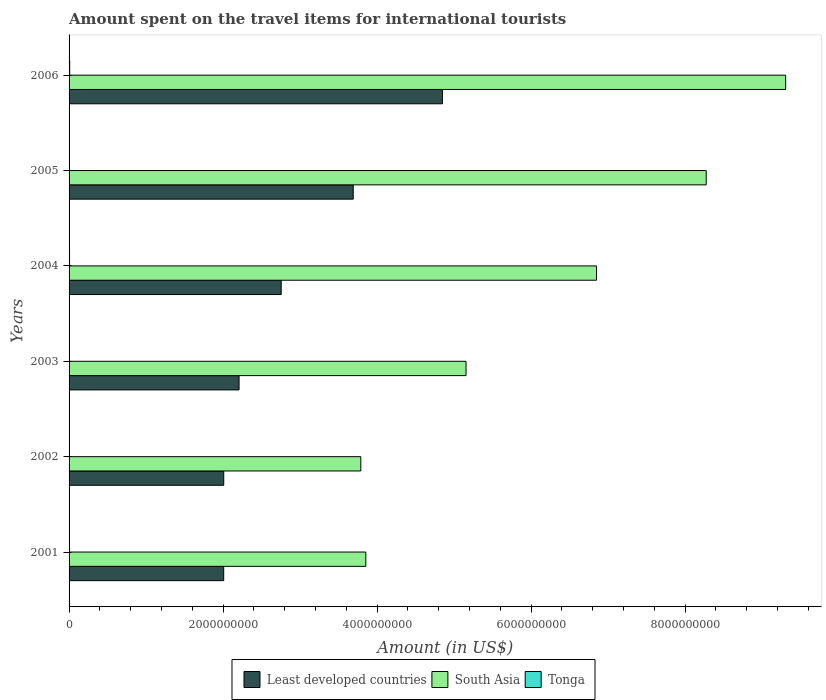Are the number of bars per tick equal to the number of legend labels?
Offer a very short reply. Yes. How many bars are there on the 2nd tick from the bottom?
Your answer should be very brief. 3. In how many cases, is the number of bars for a given year not equal to the number of legend labels?
Provide a succinct answer. 0. What is the amount spent on the travel items for international tourists in South Asia in 2006?
Keep it short and to the point. 9.31e+09. Across all years, what is the maximum amount spent on the travel items for international tourists in South Asia?
Provide a short and direct response. 9.31e+09. Across all years, what is the minimum amount spent on the travel items for international tourists in South Asia?
Offer a terse response. 3.79e+09. In which year was the amount spent on the travel items for international tourists in Tonga maximum?
Make the answer very short. 2006. What is the total amount spent on the travel items for international tourists in Tonga in the graph?
Your answer should be very brief. 2.77e+07. What is the difference between the amount spent on the travel items for international tourists in South Asia in 2005 and that in 2006?
Provide a succinct answer. -1.03e+09. What is the difference between the amount spent on the travel items for international tourists in Least developed countries in 2005 and the amount spent on the travel items for international tourists in South Asia in 2003?
Provide a succinct answer. -1.47e+09. What is the average amount spent on the travel items for international tourists in Tonga per year?
Keep it short and to the point. 4.62e+06. In the year 2002, what is the difference between the amount spent on the travel items for international tourists in Least developed countries and amount spent on the travel items for international tourists in South Asia?
Give a very brief answer. -1.78e+09. What is the ratio of the amount spent on the travel items for international tourists in South Asia in 2001 to that in 2005?
Offer a very short reply. 0.47. Is the amount spent on the travel items for international tourists in Tonga in 2003 less than that in 2004?
Your answer should be very brief. Yes. Is the difference between the amount spent on the travel items for international tourists in Least developed countries in 2003 and 2006 greater than the difference between the amount spent on the travel items for international tourists in South Asia in 2003 and 2006?
Provide a short and direct response. Yes. What is the difference between the highest and the second highest amount spent on the travel items for international tourists in Least developed countries?
Your answer should be compact. 1.16e+09. What is the difference between the highest and the lowest amount spent on the travel items for international tourists in South Asia?
Offer a terse response. 5.52e+09. What does the 3rd bar from the top in 2004 represents?
Offer a terse response. Least developed countries. What does the 1st bar from the bottom in 2004 represents?
Your answer should be very brief. Least developed countries. Is it the case that in every year, the sum of the amount spent on the travel items for international tourists in South Asia and amount spent on the travel items for international tourists in Tonga is greater than the amount spent on the travel items for international tourists in Least developed countries?
Your answer should be compact. Yes. Are all the bars in the graph horizontal?
Your response must be concise. Yes. Are the values on the major ticks of X-axis written in scientific E-notation?
Give a very brief answer. No. How are the legend labels stacked?
Offer a very short reply. Horizontal. What is the title of the graph?
Your answer should be compact. Amount spent on the travel items for international tourists. What is the Amount (in US$) of Least developed countries in 2001?
Make the answer very short. 2.01e+09. What is the Amount (in US$) of South Asia in 2001?
Give a very brief answer. 3.85e+09. What is the Amount (in US$) in Tonga in 2001?
Make the answer very short. 3.20e+06. What is the Amount (in US$) of Least developed countries in 2002?
Keep it short and to the point. 2.01e+09. What is the Amount (in US$) of South Asia in 2002?
Provide a short and direct response. 3.79e+09. What is the Amount (in US$) of Tonga in 2002?
Make the answer very short. 3.20e+06. What is the Amount (in US$) of Least developed countries in 2003?
Offer a terse response. 2.21e+09. What is the Amount (in US$) in South Asia in 2003?
Make the answer very short. 5.16e+09. What is the Amount (in US$) in Tonga in 2003?
Your answer should be very brief. 3.30e+06. What is the Amount (in US$) of Least developed countries in 2004?
Your answer should be compact. 2.75e+09. What is the Amount (in US$) in South Asia in 2004?
Your answer should be very brief. 6.85e+09. What is the Amount (in US$) of Tonga in 2004?
Keep it short and to the point. 6.10e+06. What is the Amount (in US$) of Least developed countries in 2005?
Your answer should be very brief. 3.69e+09. What is the Amount (in US$) in South Asia in 2005?
Make the answer very short. 8.28e+09. What is the Amount (in US$) of Tonga in 2005?
Give a very brief answer. 3.80e+06. What is the Amount (in US$) of Least developed countries in 2006?
Your answer should be compact. 4.85e+09. What is the Amount (in US$) in South Asia in 2006?
Offer a terse response. 9.31e+09. What is the Amount (in US$) in Tonga in 2006?
Offer a very short reply. 8.10e+06. Across all years, what is the maximum Amount (in US$) of Least developed countries?
Your response must be concise. 4.85e+09. Across all years, what is the maximum Amount (in US$) of South Asia?
Give a very brief answer. 9.31e+09. Across all years, what is the maximum Amount (in US$) in Tonga?
Your response must be concise. 8.10e+06. Across all years, what is the minimum Amount (in US$) of Least developed countries?
Keep it short and to the point. 2.01e+09. Across all years, what is the minimum Amount (in US$) of South Asia?
Provide a succinct answer. 3.79e+09. Across all years, what is the minimum Amount (in US$) in Tonga?
Your answer should be compact. 3.20e+06. What is the total Amount (in US$) in Least developed countries in the graph?
Ensure brevity in your answer.  1.75e+1. What is the total Amount (in US$) of South Asia in the graph?
Make the answer very short. 3.72e+1. What is the total Amount (in US$) of Tonga in the graph?
Give a very brief answer. 2.77e+07. What is the difference between the Amount (in US$) of Least developed countries in 2001 and that in 2002?
Offer a very short reply. -4.81e+05. What is the difference between the Amount (in US$) in South Asia in 2001 and that in 2002?
Keep it short and to the point. 6.49e+07. What is the difference between the Amount (in US$) in Tonga in 2001 and that in 2002?
Your answer should be compact. 0. What is the difference between the Amount (in US$) in Least developed countries in 2001 and that in 2003?
Your answer should be compact. -1.99e+08. What is the difference between the Amount (in US$) of South Asia in 2001 and that in 2003?
Offer a very short reply. -1.30e+09. What is the difference between the Amount (in US$) of Least developed countries in 2001 and that in 2004?
Provide a succinct answer. -7.47e+08. What is the difference between the Amount (in US$) in South Asia in 2001 and that in 2004?
Provide a succinct answer. -3.00e+09. What is the difference between the Amount (in US$) in Tonga in 2001 and that in 2004?
Offer a terse response. -2.90e+06. What is the difference between the Amount (in US$) in Least developed countries in 2001 and that in 2005?
Offer a very short reply. -1.68e+09. What is the difference between the Amount (in US$) of South Asia in 2001 and that in 2005?
Keep it short and to the point. -4.42e+09. What is the difference between the Amount (in US$) in Tonga in 2001 and that in 2005?
Provide a succinct answer. -6.00e+05. What is the difference between the Amount (in US$) in Least developed countries in 2001 and that in 2006?
Provide a short and direct response. -2.84e+09. What is the difference between the Amount (in US$) in South Asia in 2001 and that in 2006?
Offer a very short reply. -5.45e+09. What is the difference between the Amount (in US$) of Tonga in 2001 and that in 2006?
Provide a short and direct response. -4.90e+06. What is the difference between the Amount (in US$) in Least developed countries in 2002 and that in 2003?
Provide a succinct answer. -1.99e+08. What is the difference between the Amount (in US$) in South Asia in 2002 and that in 2003?
Offer a terse response. -1.37e+09. What is the difference between the Amount (in US$) in Tonga in 2002 and that in 2003?
Your response must be concise. -1.00e+05. What is the difference between the Amount (in US$) of Least developed countries in 2002 and that in 2004?
Provide a short and direct response. -7.46e+08. What is the difference between the Amount (in US$) in South Asia in 2002 and that in 2004?
Offer a terse response. -3.06e+09. What is the difference between the Amount (in US$) in Tonga in 2002 and that in 2004?
Give a very brief answer. -2.90e+06. What is the difference between the Amount (in US$) of Least developed countries in 2002 and that in 2005?
Your answer should be very brief. -1.68e+09. What is the difference between the Amount (in US$) of South Asia in 2002 and that in 2005?
Ensure brevity in your answer.  -4.49e+09. What is the difference between the Amount (in US$) in Tonga in 2002 and that in 2005?
Ensure brevity in your answer.  -6.00e+05. What is the difference between the Amount (in US$) in Least developed countries in 2002 and that in 2006?
Keep it short and to the point. -2.84e+09. What is the difference between the Amount (in US$) of South Asia in 2002 and that in 2006?
Your response must be concise. -5.52e+09. What is the difference between the Amount (in US$) in Tonga in 2002 and that in 2006?
Your answer should be very brief. -4.90e+06. What is the difference between the Amount (in US$) in Least developed countries in 2003 and that in 2004?
Your answer should be very brief. -5.47e+08. What is the difference between the Amount (in US$) of South Asia in 2003 and that in 2004?
Ensure brevity in your answer.  -1.69e+09. What is the difference between the Amount (in US$) in Tonga in 2003 and that in 2004?
Offer a terse response. -2.80e+06. What is the difference between the Amount (in US$) in Least developed countries in 2003 and that in 2005?
Keep it short and to the point. -1.48e+09. What is the difference between the Amount (in US$) of South Asia in 2003 and that in 2005?
Offer a terse response. -3.12e+09. What is the difference between the Amount (in US$) of Tonga in 2003 and that in 2005?
Keep it short and to the point. -5.00e+05. What is the difference between the Amount (in US$) in Least developed countries in 2003 and that in 2006?
Offer a very short reply. -2.64e+09. What is the difference between the Amount (in US$) of South Asia in 2003 and that in 2006?
Give a very brief answer. -4.15e+09. What is the difference between the Amount (in US$) in Tonga in 2003 and that in 2006?
Provide a short and direct response. -4.80e+06. What is the difference between the Amount (in US$) of Least developed countries in 2004 and that in 2005?
Your answer should be very brief. -9.35e+08. What is the difference between the Amount (in US$) in South Asia in 2004 and that in 2005?
Offer a terse response. -1.42e+09. What is the difference between the Amount (in US$) in Tonga in 2004 and that in 2005?
Offer a very short reply. 2.30e+06. What is the difference between the Amount (in US$) in Least developed countries in 2004 and that in 2006?
Keep it short and to the point. -2.09e+09. What is the difference between the Amount (in US$) of South Asia in 2004 and that in 2006?
Offer a very short reply. -2.46e+09. What is the difference between the Amount (in US$) of Tonga in 2004 and that in 2006?
Provide a succinct answer. -2.00e+06. What is the difference between the Amount (in US$) of Least developed countries in 2005 and that in 2006?
Your response must be concise. -1.16e+09. What is the difference between the Amount (in US$) in South Asia in 2005 and that in 2006?
Your answer should be compact. -1.03e+09. What is the difference between the Amount (in US$) in Tonga in 2005 and that in 2006?
Keep it short and to the point. -4.30e+06. What is the difference between the Amount (in US$) in Least developed countries in 2001 and the Amount (in US$) in South Asia in 2002?
Make the answer very short. -1.78e+09. What is the difference between the Amount (in US$) of Least developed countries in 2001 and the Amount (in US$) of Tonga in 2002?
Ensure brevity in your answer.  2.01e+09. What is the difference between the Amount (in US$) in South Asia in 2001 and the Amount (in US$) in Tonga in 2002?
Offer a very short reply. 3.85e+09. What is the difference between the Amount (in US$) in Least developed countries in 2001 and the Amount (in US$) in South Asia in 2003?
Offer a terse response. -3.15e+09. What is the difference between the Amount (in US$) in Least developed countries in 2001 and the Amount (in US$) in Tonga in 2003?
Give a very brief answer. 2.00e+09. What is the difference between the Amount (in US$) in South Asia in 2001 and the Amount (in US$) in Tonga in 2003?
Your answer should be compact. 3.85e+09. What is the difference between the Amount (in US$) in Least developed countries in 2001 and the Amount (in US$) in South Asia in 2004?
Keep it short and to the point. -4.84e+09. What is the difference between the Amount (in US$) of Least developed countries in 2001 and the Amount (in US$) of Tonga in 2004?
Offer a very short reply. 2.00e+09. What is the difference between the Amount (in US$) in South Asia in 2001 and the Amount (in US$) in Tonga in 2004?
Your response must be concise. 3.85e+09. What is the difference between the Amount (in US$) in Least developed countries in 2001 and the Amount (in US$) in South Asia in 2005?
Provide a succinct answer. -6.27e+09. What is the difference between the Amount (in US$) in Least developed countries in 2001 and the Amount (in US$) in Tonga in 2005?
Give a very brief answer. 2.00e+09. What is the difference between the Amount (in US$) of South Asia in 2001 and the Amount (in US$) of Tonga in 2005?
Give a very brief answer. 3.85e+09. What is the difference between the Amount (in US$) of Least developed countries in 2001 and the Amount (in US$) of South Asia in 2006?
Keep it short and to the point. -7.30e+09. What is the difference between the Amount (in US$) in Least developed countries in 2001 and the Amount (in US$) in Tonga in 2006?
Ensure brevity in your answer.  2.00e+09. What is the difference between the Amount (in US$) of South Asia in 2001 and the Amount (in US$) of Tonga in 2006?
Provide a succinct answer. 3.85e+09. What is the difference between the Amount (in US$) in Least developed countries in 2002 and the Amount (in US$) in South Asia in 2003?
Offer a terse response. -3.15e+09. What is the difference between the Amount (in US$) in Least developed countries in 2002 and the Amount (in US$) in Tonga in 2003?
Keep it short and to the point. 2.01e+09. What is the difference between the Amount (in US$) of South Asia in 2002 and the Amount (in US$) of Tonga in 2003?
Offer a terse response. 3.79e+09. What is the difference between the Amount (in US$) of Least developed countries in 2002 and the Amount (in US$) of South Asia in 2004?
Your answer should be compact. -4.84e+09. What is the difference between the Amount (in US$) of Least developed countries in 2002 and the Amount (in US$) of Tonga in 2004?
Provide a short and direct response. 2.00e+09. What is the difference between the Amount (in US$) in South Asia in 2002 and the Amount (in US$) in Tonga in 2004?
Provide a short and direct response. 3.78e+09. What is the difference between the Amount (in US$) in Least developed countries in 2002 and the Amount (in US$) in South Asia in 2005?
Keep it short and to the point. -6.27e+09. What is the difference between the Amount (in US$) of Least developed countries in 2002 and the Amount (in US$) of Tonga in 2005?
Make the answer very short. 2.00e+09. What is the difference between the Amount (in US$) in South Asia in 2002 and the Amount (in US$) in Tonga in 2005?
Give a very brief answer. 3.79e+09. What is the difference between the Amount (in US$) of Least developed countries in 2002 and the Amount (in US$) of South Asia in 2006?
Keep it short and to the point. -7.30e+09. What is the difference between the Amount (in US$) in Least developed countries in 2002 and the Amount (in US$) in Tonga in 2006?
Your answer should be very brief. 2.00e+09. What is the difference between the Amount (in US$) in South Asia in 2002 and the Amount (in US$) in Tonga in 2006?
Your answer should be compact. 3.78e+09. What is the difference between the Amount (in US$) of Least developed countries in 2003 and the Amount (in US$) of South Asia in 2004?
Your answer should be very brief. -4.64e+09. What is the difference between the Amount (in US$) in Least developed countries in 2003 and the Amount (in US$) in Tonga in 2004?
Ensure brevity in your answer.  2.20e+09. What is the difference between the Amount (in US$) in South Asia in 2003 and the Amount (in US$) in Tonga in 2004?
Make the answer very short. 5.15e+09. What is the difference between the Amount (in US$) in Least developed countries in 2003 and the Amount (in US$) in South Asia in 2005?
Your answer should be very brief. -6.07e+09. What is the difference between the Amount (in US$) of Least developed countries in 2003 and the Amount (in US$) of Tonga in 2005?
Your answer should be very brief. 2.20e+09. What is the difference between the Amount (in US$) of South Asia in 2003 and the Amount (in US$) of Tonga in 2005?
Offer a terse response. 5.15e+09. What is the difference between the Amount (in US$) of Least developed countries in 2003 and the Amount (in US$) of South Asia in 2006?
Your response must be concise. -7.10e+09. What is the difference between the Amount (in US$) in Least developed countries in 2003 and the Amount (in US$) in Tonga in 2006?
Keep it short and to the point. 2.20e+09. What is the difference between the Amount (in US$) in South Asia in 2003 and the Amount (in US$) in Tonga in 2006?
Your answer should be compact. 5.15e+09. What is the difference between the Amount (in US$) in Least developed countries in 2004 and the Amount (in US$) in South Asia in 2005?
Ensure brevity in your answer.  -5.52e+09. What is the difference between the Amount (in US$) in Least developed countries in 2004 and the Amount (in US$) in Tonga in 2005?
Give a very brief answer. 2.75e+09. What is the difference between the Amount (in US$) in South Asia in 2004 and the Amount (in US$) in Tonga in 2005?
Offer a very short reply. 6.85e+09. What is the difference between the Amount (in US$) in Least developed countries in 2004 and the Amount (in US$) in South Asia in 2006?
Offer a very short reply. -6.55e+09. What is the difference between the Amount (in US$) of Least developed countries in 2004 and the Amount (in US$) of Tonga in 2006?
Your answer should be very brief. 2.75e+09. What is the difference between the Amount (in US$) of South Asia in 2004 and the Amount (in US$) of Tonga in 2006?
Offer a very short reply. 6.84e+09. What is the difference between the Amount (in US$) of Least developed countries in 2005 and the Amount (in US$) of South Asia in 2006?
Provide a short and direct response. -5.62e+09. What is the difference between the Amount (in US$) of Least developed countries in 2005 and the Amount (in US$) of Tonga in 2006?
Offer a terse response. 3.68e+09. What is the difference between the Amount (in US$) in South Asia in 2005 and the Amount (in US$) in Tonga in 2006?
Ensure brevity in your answer.  8.27e+09. What is the average Amount (in US$) of Least developed countries per year?
Keep it short and to the point. 2.92e+09. What is the average Amount (in US$) of South Asia per year?
Provide a succinct answer. 6.21e+09. What is the average Amount (in US$) of Tonga per year?
Make the answer very short. 4.62e+06. In the year 2001, what is the difference between the Amount (in US$) of Least developed countries and Amount (in US$) of South Asia?
Make the answer very short. -1.85e+09. In the year 2001, what is the difference between the Amount (in US$) of Least developed countries and Amount (in US$) of Tonga?
Give a very brief answer. 2.01e+09. In the year 2001, what is the difference between the Amount (in US$) in South Asia and Amount (in US$) in Tonga?
Offer a very short reply. 3.85e+09. In the year 2002, what is the difference between the Amount (in US$) in Least developed countries and Amount (in US$) in South Asia?
Your answer should be compact. -1.78e+09. In the year 2002, what is the difference between the Amount (in US$) of Least developed countries and Amount (in US$) of Tonga?
Provide a short and direct response. 2.01e+09. In the year 2002, what is the difference between the Amount (in US$) of South Asia and Amount (in US$) of Tonga?
Your response must be concise. 3.79e+09. In the year 2003, what is the difference between the Amount (in US$) in Least developed countries and Amount (in US$) in South Asia?
Your answer should be very brief. -2.95e+09. In the year 2003, what is the difference between the Amount (in US$) in Least developed countries and Amount (in US$) in Tonga?
Make the answer very short. 2.20e+09. In the year 2003, what is the difference between the Amount (in US$) in South Asia and Amount (in US$) in Tonga?
Ensure brevity in your answer.  5.15e+09. In the year 2004, what is the difference between the Amount (in US$) in Least developed countries and Amount (in US$) in South Asia?
Give a very brief answer. -4.10e+09. In the year 2004, what is the difference between the Amount (in US$) in Least developed countries and Amount (in US$) in Tonga?
Provide a short and direct response. 2.75e+09. In the year 2004, what is the difference between the Amount (in US$) in South Asia and Amount (in US$) in Tonga?
Keep it short and to the point. 6.84e+09. In the year 2005, what is the difference between the Amount (in US$) of Least developed countries and Amount (in US$) of South Asia?
Offer a terse response. -4.58e+09. In the year 2005, what is the difference between the Amount (in US$) in Least developed countries and Amount (in US$) in Tonga?
Make the answer very short. 3.69e+09. In the year 2005, what is the difference between the Amount (in US$) of South Asia and Amount (in US$) of Tonga?
Keep it short and to the point. 8.27e+09. In the year 2006, what is the difference between the Amount (in US$) in Least developed countries and Amount (in US$) in South Asia?
Your response must be concise. -4.46e+09. In the year 2006, what is the difference between the Amount (in US$) of Least developed countries and Amount (in US$) of Tonga?
Ensure brevity in your answer.  4.84e+09. In the year 2006, what is the difference between the Amount (in US$) in South Asia and Amount (in US$) in Tonga?
Your response must be concise. 9.30e+09. What is the ratio of the Amount (in US$) in South Asia in 2001 to that in 2002?
Give a very brief answer. 1.02. What is the ratio of the Amount (in US$) in Least developed countries in 2001 to that in 2003?
Your answer should be compact. 0.91. What is the ratio of the Amount (in US$) in South Asia in 2001 to that in 2003?
Offer a very short reply. 0.75. What is the ratio of the Amount (in US$) of Tonga in 2001 to that in 2003?
Give a very brief answer. 0.97. What is the ratio of the Amount (in US$) of Least developed countries in 2001 to that in 2004?
Give a very brief answer. 0.73. What is the ratio of the Amount (in US$) of South Asia in 2001 to that in 2004?
Offer a very short reply. 0.56. What is the ratio of the Amount (in US$) of Tonga in 2001 to that in 2004?
Ensure brevity in your answer.  0.52. What is the ratio of the Amount (in US$) in Least developed countries in 2001 to that in 2005?
Keep it short and to the point. 0.54. What is the ratio of the Amount (in US$) of South Asia in 2001 to that in 2005?
Offer a very short reply. 0.47. What is the ratio of the Amount (in US$) in Tonga in 2001 to that in 2005?
Your response must be concise. 0.84. What is the ratio of the Amount (in US$) in Least developed countries in 2001 to that in 2006?
Make the answer very short. 0.41. What is the ratio of the Amount (in US$) in South Asia in 2001 to that in 2006?
Offer a terse response. 0.41. What is the ratio of the Amount (in US$) of Tonga in 2001 to that in 2006?
Offer a terse response. 0.4. What is the ratio of the Amount (in US$) of Least developed countries in 2002 to that in 2003?
Provide a short and direct response. 0.91. What is the ratio of the Amount (in US$) in South Asia in 2002 to that in 2003?
Your answer should be very brief. 0.73. What is the ratio of the Amount (in US$) in Tonga in 2002 to that in 2003?
Your answer should be very brief. 0.97. What is the ratio of the Amount (in US$) in Least developed countries in 2002 to that in 2004?
Ensure brevity in your answer.  0.73. What is the ratio of the Amount (in US$) of South Asia in 2002 to that in 2004?
Give a very brief answer. 0.55. What is the ratio of the Amount (in US$) of Tonga in 2002 to that in 2004?
Your response must be concise. 0.52. What is the ratio of the Amount (in US$) in Least developed countries in 2002 to that in 2005?
Your answer should be compact. 0.54. What is the ratio of the Amount (in US$) in South Asia in 2002 to that in 2005?
Offer a very short reply. 0.46. What is the ratio of the Amount (in US$) in Tonga in 2002 to that in 2005?
Give a very brief answer. 0.84. What is the ratio of the Amount (in US$) of Least developed countries in 2002 to that in 2006?
Make the answer very short. 0.41. What is the ratio of the Amount (in US$) of South Asia in 2002 to that in 2006?
Offer a very short reply. 0.41. What is the ratio of the Amount (in US$) in Tonga in 2002 to that in 2006?
Your answer should be compact. 0.4. What is the ratio of the Amount (in US$) of Least developed countries in 2003 to that in 2004?
Your answer should be very brief. 0.8. What is the ratio of the Amount (in US$) in South Asia in 2003 to that in 2004?
Offer a terse response. 0.75. What is the ratio of the Amount (in US$) in Tonga in 2003 to that in 2004?
Ensure brevity in your answer.  0.54. What is the ratio of the Amount (in US$) in Least developed countries in 2003 to that in 2005?
Make the answer very short. 0.6. What is the ratio of the Amount (in US$) in South Asia in 2003 to that in 2005?
Offer a very short reply. 0.62. What is the ratio of the Amount (in US$) in Tonga in 2003 to that in 2005?
Give a very brief answer. 0.87. What is the ratio of the Amount (in US$) in Least developed countries in 2003 to that in 2006?
Make the answer very short. 0.46. What is the ratio of the Amount (in US$) of South Asia in 2003 to that in 2006?
Your answer should be very brief. 0.55. What is the ratio of the Amount (in US$) in Tonga in 2003 to that in 2006?
Your answer should be very brief. 0.41. What is the ratio of the Amount (in US$) in Least developed countries in 2004 to that in 2005?
Your answer should be very brief. 0.75. What is the ratio of the Amount (in US$) of South Asia in 2004 to that in 2005?
Offer a very short reply. 0.83. What is the ratio of the Amount (in US$) in Tonga in 2004 to that in 2005?
Your answer should be compact. 1.61. What is the ratio of the Amount (in US$) in Least developed countries in 2004 to that in 2006?
Your response must be concise. 0.57. What is the ratio of the Amount (in US$) in South Asia in 2004 to that in 2006?
Keep it short and to the point. 0.74. What is the ratio of the Amount (in US$) of Tonga in 2004 to that in 2006?
Give a very brief answer. 0.75. What is the ratio of the Amount (in US$) in Least developed countries in 2005 to that in 2006?
Your answer should be very brief. 0.76. What is the ratio of the Amount (in US$) in South Asia in 2005 to that in 2006?
Offer a terse response. 0.89. What is the ratio of the Amount (in US$) in Tonga in 2005 to that in 2006?
Your answer should be very brief. 0.47. What is the difference between the highest and the second highest Amount (in US$) in Least developed countries?
Ensure brevity in your answer.  1.16e+09. What is the difference between the highest and the second highest Amount (in US$) in South Asia?
Your answer should be compact. 1.03e+09. What is the difference between the highest and the lowest Amount (in US$) of Least developed countries?
Offer a terse response. 2.84e+09. What is the difference between the highest and the lowest Amount (in US$) in South Asia?
Keep it short and to the point. 5.52e+09. What is the difference between the highest and the lowest Amount (in US$) in Tonga?
Ensure brevity in your answer.  4.90e+06. 